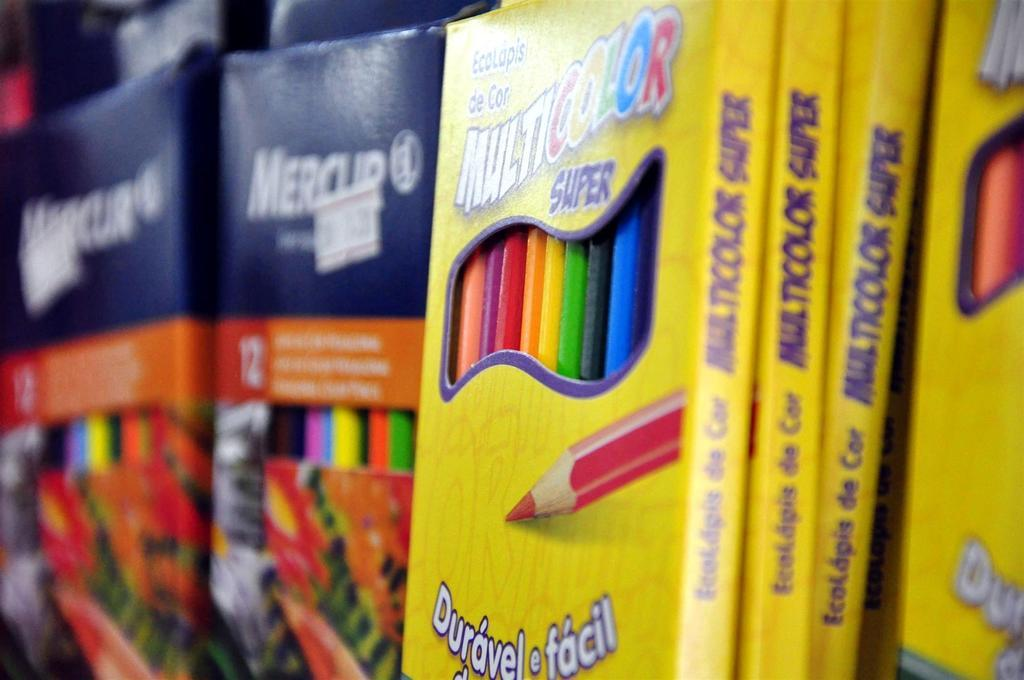<image>
Relay a brief, clear account of the picture shown. A yellow packet of colouring pencils with foreign writing on it. 